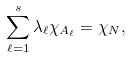<formula> <loc_0><loc_0><loc_500><loc_500>\sum _ { \ell = 1 } ^ { s } \lambda _ { \ell } \chi _ { A _ { \ell } } = \chi _ { N } ,</formula> 